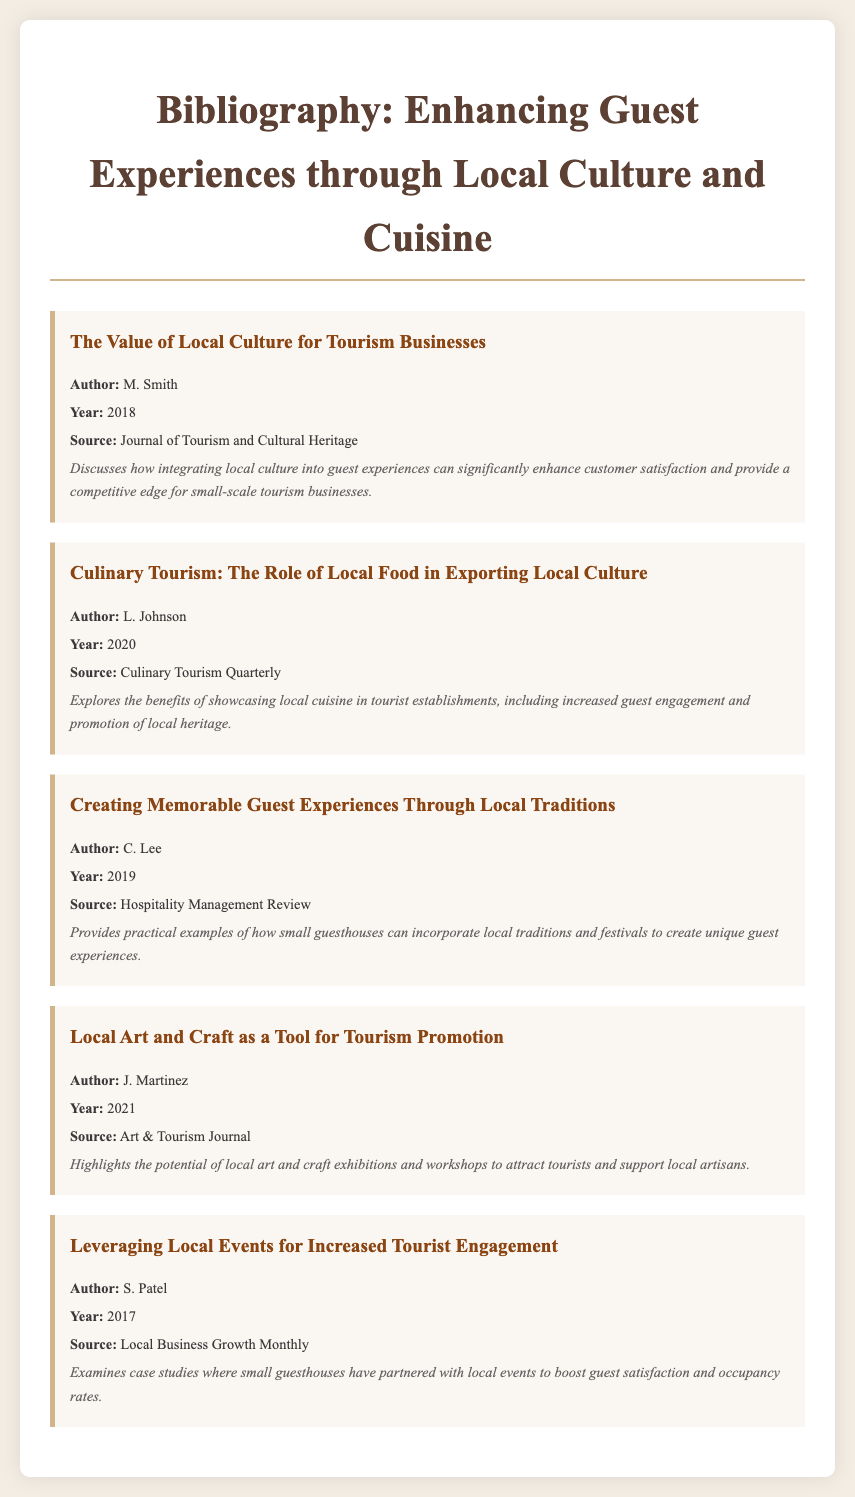What is the title of the first entry? The title of the first entry can be found at the top of the first bibliography item.
Answer: The Value of Local Culture for Tourism Businesses Who is the author of "Culinary Tourism: The Role of Local Food in Exporting Local Culture"? The author's name is mentioned below the title in the bibliography item regarding culinary tourism.
Answer: L. Johnson In what year was "Creating Memorable Guest Experiences Through Local Traditions" published? The publication year is located under the author's name in the third bibliography item.
Answer: 2019 Which source published the article by J. Martinez? The source is specified in the bibliography item and indicates where the article was published.
Answer: Art & Tourism Journal How many bibliography entries are authored by individuals with a last name starting with 'M'? This number can be determined by counting the entries authored by individuals with 'M' as their last name.
Answer: 2 What common theme do the articles in this bibliography share? The theme can be inferred from the titles and summaries of the bibliography items.
Answer: Local culture and cuisine Does the bibliography mention any case studies related to small guesthouses? The existence of case studies can be identified in the context of specific articles mentioned in the document.
Answer: Yes What is the focus of the article by S. Patel? The focus can be discerned from the summary provided in the bibliography entry.
Answer: Local events for increased tourist engagement 